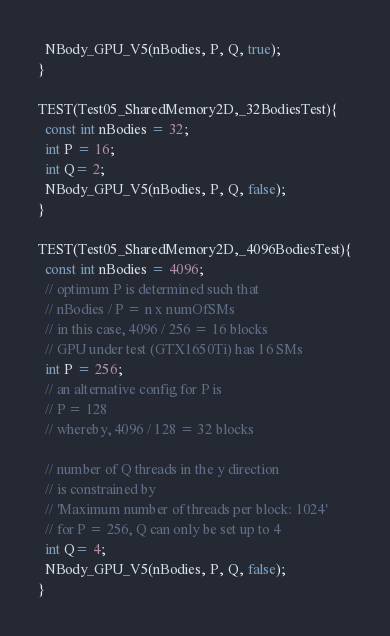<code> <loc_0><loc_0><loc_500><loc_500><_Cuda_>  NBody_GPU_V5(nBodies, P, Q, true);
}

TEST(Test05_SharedMemory2D,_32BodiesTest){
  const int nBodies = 32;
  int P = 16;
  int Q= 2;
  NBody_GPU_V5(nBodies, P, Q, false);
}

TEST(Test05_SharedMemory2D,_4096BodiesTest){
  const int nBodies = 4096;
  // optimum P is determined such that 
  // nBodies / P = n x numOfSMs
  // in this case, 4096 / 256 = 16 blocks 
  // GPU under test (GTX1650Ti) has 16 SMs
  int P = 256;
  // an alternative config for P is
  // P = 128
  // whereby, 4096 / 128 = 32 blocks 

  // number of Q threads in the y direction
  // is constrained by 
  // 'Maximum number of threads per block: 1024'
  // for P = 256, Q can only be set up to 4
  int Q= 4;
  NBody_GPU_V5(nBodies, P, Q, false);
}</code> 